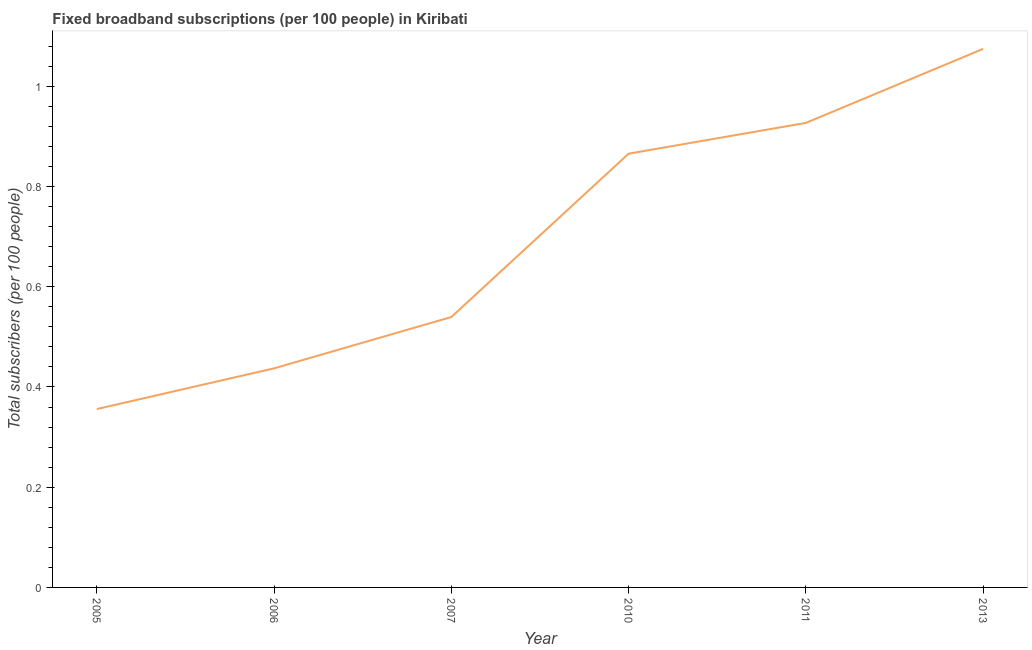What is the total number of fixed broadband subscriptions in 2006?
Give a very brief answer. 0.44. Across all years, what is the maximum total number of fixed broadband subscriptions?
Provide a succinct answer. 1.07. Across all years, what is the minimum total number of fixed broadband subscriptions?
Give a very brief answer. 0.36. In which year was the total number of fixed broadband subscriptions minimum?
Offer a terse response. 2005. What is the sum of the total number of fixed broadband subscriptions?
Provide a short and direct response. 4.2. What is the difference between the total number of fixed broadband subscriptions in 2005 and 2010?
Your answer should be very brief. -0.51. What is the average total number of fixed broadband subscriptions per year?
Give a very brief answer. 0.7. What is the median total number of fixed broadband subscriptions?
Provide a short and direct response. 0.7. In how many years, is the total number of fixed broadband subscriptions greater than 1 ?
Your response must be concise. 1. What is the ratio of the total number of fixed broadband subscriptions in 2010 to that in 2013?
Give a very brief answer. 0.81. Is the total number of fixed broadband subscriptions in 2006 less than that in 2007?
Your response must be concise. Yes. Is the difference between the total number of fixed broadband subscriptions in 2005 and 2011 greater than the difference between any two years?
Give a very brief answer. No. What is the difference between the highest and the second highest total number of fixed broadband subscriptions?
Give a very brief answer. 0.15. What is the difference between the highest and the lowest total number of fixed broadband subscriptions?
Your answer should be very brief. 0.72. Does the total number of fixed broadband subscriptions monotonically increase over the years?
Give a very brief answer. Yes. How many lines are there?
Keep it short and to the point. 1. What is the difference between two consecutive major ticks on the Y-axis?
Make the answer very short. 0.2. Does the graph contain any zero values?
Give a very brief answer. No. Does the graph contain grids?
Your response must be concise. No. What is the title of the graph?
Provide a short and direct response. Fixed broadband subscriptions (per 100 people) in Kiribati. What is the label or title of the X-axis?
Offer a terse response. Year. What is the label or title of the Y-axis?
Your answer should be very brief. Total subscribers (per 100 people). What is the Total subscribers (per 100 people) in 2005?
Offer a terse response. 0.36. What is the Total subscribers (per 100 people) of 2006?
Offer a terse response. 0.44. What is the Total subscribers (per 100 people) of 2007?
Make the answer very short. 0.54. What is the Total subscribers (per 100 people) of 2010?
Your response must be concise. 0.87. What is the Total subscribers (per 100 people) in 2011?
Keep it short and to the point. 0.93. What is the Total subscribers (per 100 people) of 2013?
Ensure brevity in your answer.  1.07. What is the difference between the Total subscribers (per 100 people) in 2005 and 2006?
Your answer should be compact. -0.08. What is the difference between the Total subscribers (per 100 people) in 2005 and 2007?
Provide a succinct answer. -0.18. What is the difference between the Total subscribers (per 100 people) in 2005 and 2010?
Your response must be concise. -0.51. What is the difference between the Total subscribers (per 100 people) in 2005 and 2011?
Your response must be concise. -0.57. What is the difference between the Total subscribers (per 100 people) in 2005 and 2013?
Offer a terse response. -0.72. What is the difference between the Total subscribers (per 100 people) in 2006 and 2007?
Make the answer very short. -0.1. What is the difference between the Total subscribers (per 100 people) in 2006 and 2010?
Provide a short and direct response. -0.43. What is the difference between the Total subscribers (per 100 people) in 2006 and 2011?
Provide a succinct answer. -0.49. What is the difference between the Total subscribers (per 100 people) in 2006 and 2013?
Your answer should be very brief. -0.64. What is the difference between the Total subscribers (per 100 people) in 2007 and 2010?
Your response must be concise. -0.33. What is the difference between the Total subscribers (per 100 people) in 2007 and 2011?
Keep it short and to the point. -0.39. What is the difference between the Total subscribers (per 100 people) in 2007 and 2013?
Give a very brief answer. -0.54. What is the difference between the Total subscribers (per 100 people) in 2010 and 2011?
Offer a very short reply. -0.06. What is the difference between the Total subscribers (per 100 people) in 2010 and 2013?
Your response must be concise. -0.21. What is the difference between the Total subscribers (per 100 people) in 2011 and 2013?
Provide a short and direct response. -0.15. What is the ratio of the Total subscribers (per 100 people) in 2005 to that in 2006?
Offer a very short reply. 0.81. What is the ratio of the Total subscribers (per 100 people) in 2005 to that in 2007?
Ensure brevity in your answer.  0.66. What is the ratio of the Total subscribers (per 100 people) in 2005 to that in 2010?
Give a very brief answer. 0.41. What is the ratio of the Total subscribers (per 100 people) in 2005 to that in 2011?
Offer a very short reply. 0.38. What is the ratio of the Total subscribers (per 100 people) in 2005 to that in 2013?
Your answer should be compact. 0.33. What is the ratio of the Total subscribers (per 100 people) in 2006 to that in 2007?
Offer a terse response. 0.81. What is the ratio of the Total subscribers (per 100 people) in 2006 to that in 2010?
Offer a terse response. 0.51. What is the ratio of the Total subscribers (per 100 people) in 2006 to that in 2011?
Your response must be concise. 0.47. What is the ratio of the Total subscribers (per 100 people) in 2006 to that in 2013?
Your response must be concise. 0.41. What is the ratio of the Total subscribers (per 100 people) in 2007 to that in 2010?
Keep it short and to the point. 0.62. What is the ratio of the Total subscribers (per 100 people) in 2007 to that in 2011?
Your answer should be compact. 0.58. What is the ratio of the Total subscribers (per 100 people) in 2007 to that in 2013?
Provide a short and direct response. 0.5. What is the ratio of the Total subscribers (per 100 people) in 2010 to that in 2011?
Ensure brevity in your answer.  0.93. What is the ratio of the Total subscribers (per 100 people) in 2010 to that in 2013?
Provide a succinct answer. 0.81. What is the ratio of the Total subscribers (per 100 people) in 2011 to that in 2013?
Provide a short and direct response. 0.86. 